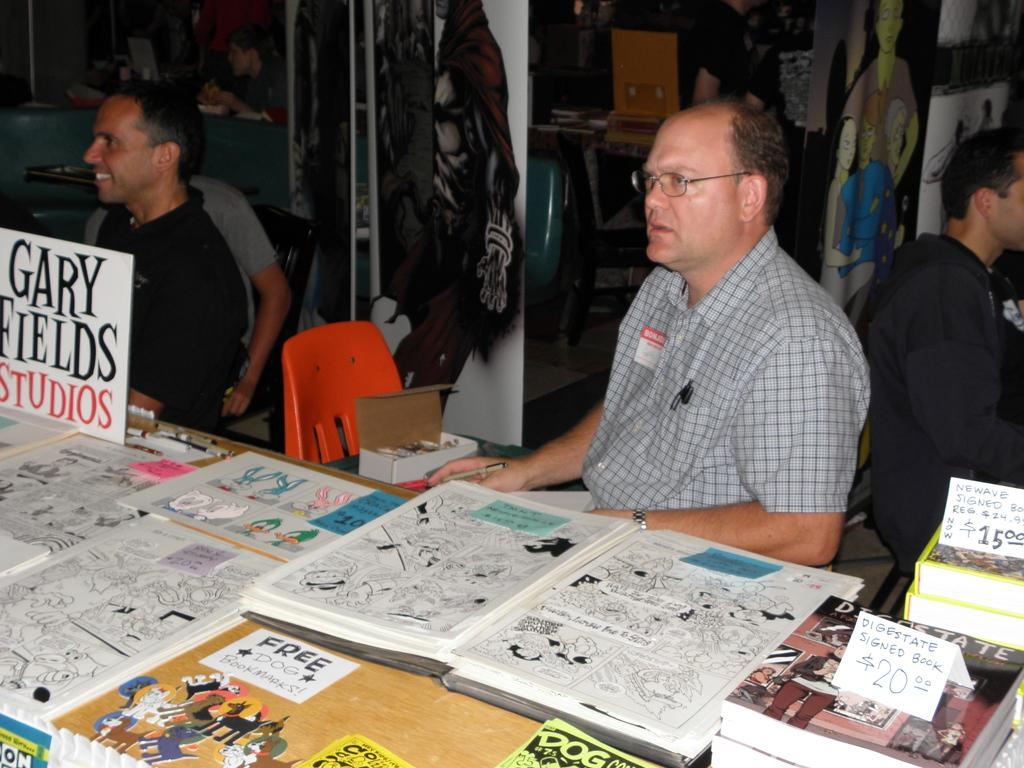<image>
Relay a brief, clear account of the picture shown. A man sitting at a table with different comics displayed and a sign that reads "Gary Fields Studios" 